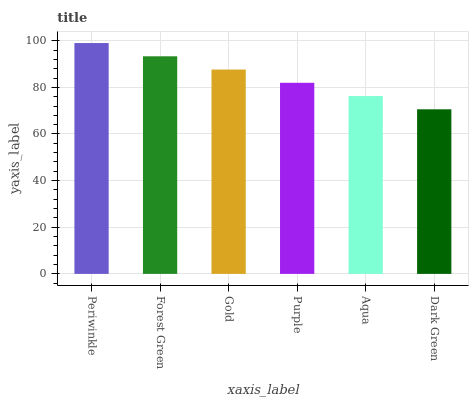Is Dark Green the minimum?
Answer yes or no. Yes. Is Periwinkle the maximum?
Answer yes or no. Yes. Is Forest Green the minimum?
Answer yes or no. No. Is Forest Green the maximum?
Answer yes or no. No. Is Periwinkle greater than Forest Green?
Answer yes or no. Yes. Is Forest Green less than Periwinkle?
Answer yes or no. Yes. Is Forest Green greater than Periwinkle?
Answer yes or no. No. Is Periwinkle less than Forest Green?
Answer yes or no. No. Is Gold the high median?
Answer yes or no. Yes. Is Purple the low median?
Answer yes or no. Yes. Is Purple the high median?
Answer yes or no. No. Is Gold the low median?
Answer yes or no. No. 